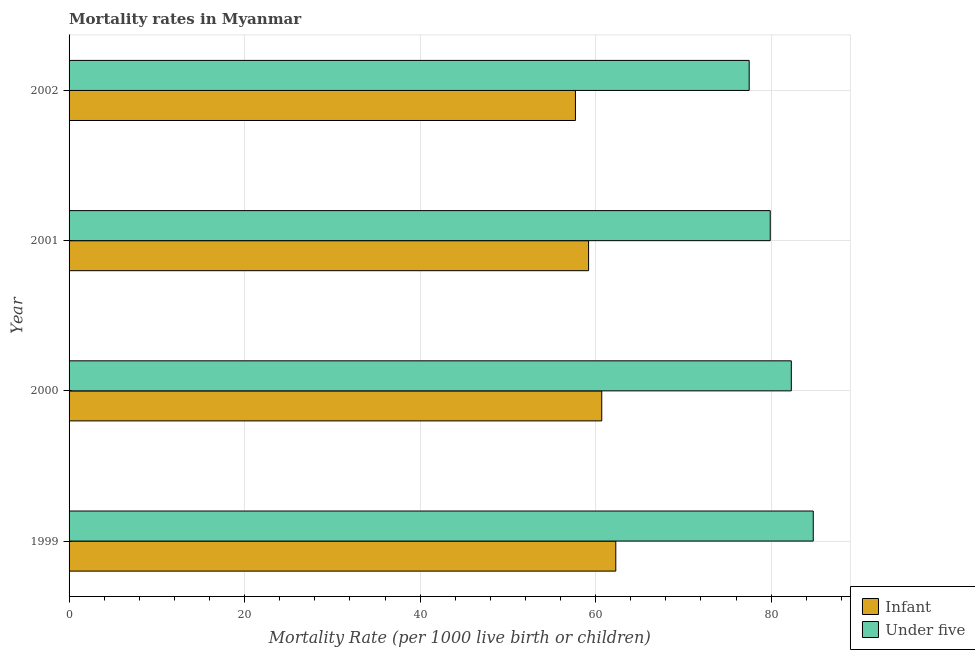How many groups of bars are there?
Ensure brevity in your answer.  4. Are the number of bars on each tick of the Y-axis equal?
Your response must be concise. Yes. How many bars are there on the 2nd tick from the top?
Provide a succinct answer. 2. How many bars are there on the 1st tick from the bottom?
Your answer should be very brief. 2. In how many cases, is the number of bars for a given year not equal to the number of legend labels?
Ensure brevity in your answer.  0. What is the under-5 mortality rate in 2001?
Ensure brevity in your answer.  79.9. Across all years, what is the maximum infant mortality rate?
Ensure brevity in your answer.  62.3. Across all years, what is the minimum under-5 mortality rate?
Keep it short and to the point. 77.5. In which year was the infant mortality rate maximum?
Offer a very short reply. 1999. In which year was the under-5 mortality rate minimum?
Your answer should be very brief. 2002. What is the total under-5 mortality rate in the graph?
Your answer should be very brief. 324.5. What is the difference between the under-5 mortality rate in 2000 and that in 2002?
Your answer should be compact. 4.8. What is the difference between the under-5 mortality rate in 2002 and the infant mortality rate in 2000?
Your answer should be very brief. 16.8. What is the average under-5 mortality rate per year?
Give a very brief answer. 81.12. In the year 1999, what is the difference between the under-5 mortality rate and infant mortality rate?
Provide a short and direct response. 22.5. What is the ratio of the infant mortality rate in 1999 to that in 2001?
Your answer should be compact. 1.05. Is the infant mortality rate in 2000 less than that in 2002?
Make the answer very short. No. Is the difference between the infant mortality rate in 2001 and 2002 greater than the difference between the under-5 mortality rate in 2001 and 2002?
Provide a short and direct response. No. What is the difference between the highest and the lowest under-5 mortality rate?
Your response must be concise. 7.3. In how many years, is the infant mortality rate greater than the average infant mortality rate taken over all years?
Your answer should be compact. 2. What does the 2nd bar from the top in 2000 represents?
Offer a very short reply. Infant. What does the 2nd bar from the bottom in 2000 represents?
Ensure brevity in your answer.  Under five. How many bars are there?
Keep it short and to the point. 8. What is the difference between two consecutive major ticks on the X-axis?
Offer a very short reply. 20. Does the graph contain any zero values?
Your response must be concise. No. What is the title of the graph?
Offer a very short reply. Mortality rates in Myanmar. What is the label or title of the X-axis?
Provide a short and direct response. Mortality Rate (per 1000 live birth or children). What is the label or title of the Y-axis?
Give a very brief answer. Year. What is the Mortality Rate (per 1000 live birth or children) of Infant in 1999?
Offer a very short reply. 62.3. What is the Mortality Rate (per 1000 live birth or children) in Under five in 1999?
Offer a very short reply. 84.8. What is the Mortality Rate (per 1000 live birth or children) in Infant in 2000?
Your response must be concise. 60.7. What is the Mortality Rate (per 1000 live birth or children) in Under five in 2000?
Ensure brevity in your answer.  82.3. What is the Mortality Rate (per 1000 live birth or children) in Infant in 2001?
Make the answer very short. 59.2. What is the Mortality Rate (per 1000 live birth or children) of Under five in 2001?
Ensure brevity in your answer.  79.9. What is the Mortality Rate (per 1000 live birth or children) in Infant in 2002?
Ensure brevity in your answer.  57.7. What is the Mortality Rate (per 1000 live birth or children) in Under five in 2002?
Your answer should be compact. 77.5. Across all years, what is the maximum Mortality Rate (per 1000 live birth or children) of Infant?
Offer a very short reply. 62.3. Across all years, what is the maximum Mortality Rate (per 1000 live birth or children) in Under five?
Provide a succinct answer. 84.8. Across all years, what is the minimum Mortality Rate (per 1000 live birth or children) in Infant?
Offer a very short reply. 57.7. Across all years, what is the minimum Mortality Rate (per 1000 live birth or children) in Under five?
Offer a terse response. 77.5. What is the total Mortality Rate (per 1000 live birth or children) of Infant in the graph?
Make the answer very short. 239.9. What is the total Mortality Rate (per 1000 live birth or children) in Under five in the graph?
Provide a succinct answer. 324.5. What is the difference between the Mortality Rate (per 1000 live birth or children) in Under five in 1999 and that in 2000?
Keep it short and to the point. 2.5. What is the difference between the Mortality Rate (per 1000 live birth or children) in Infant in 1999 and that in 2001?
Give a very brief answer. 3.1. What is the difference between the Mortality Rate (per 1000 live birth or children) in Infant in 1999 and that in 2002?
Offer a very short reply. 4.6. What is the difference between the Mortality Rate (per 1000 live birth or children) in Under five in 1999 and that in 2002?
Offer a very short reply. 7.3. What is the difference between the Mortality Rate (per 1000 live birth or children) of Under five in 2000 and that in 2002?
Ensure brevity in your answer.  4.8. What is the difference between the Mortality Rate (per 1000 live birth or children) in Infant in 2001 and that in 2002?
Your answer should be compact. 1.5. What is the difference between the Mortality Rate (per 1000 live birth or children) of Under five in 2001 and that in 2002?
Ensure brevity in your answer.  2.4. What is the difference between the Mortality Rate (per 1000 live birth or children) of Infant in 1999 and the Mortality Rate (per 1000 live birth or children) of Under five in 2001?
Offer a very short reply. -17.6. What is the difference between the Mortality Rate (per 1000 live birth or children) in Infant in 1999 and the Mortality Rate (per 1000 live birth or children) in Under five in 2002?
Offer a very short reply. -15.2. What is the difference between the Mortality Rate (per 1000 live birth or children) of Infant in 2000 and the Mortality Rate (per 1000 live birth or children) of Under five in 2001?
Make the answer very short. -19.2. What is the difference between the Mortality Rate (per 1000 live birth or children) in Infant in 2000 and the Mortality Rate (per 1000 live birth or children) in Under five in 2002?
Ensure brevity in your answer.  -16.8. What is the difference between the Mortality Rate (per 1000 live birth or children) in Infant in 2001 and the Mortality Rate (per 1000 live birth or children) in Under five in 2002?
Offer a terse response. -18.3. What is the average Mortality Rate (per 1000 live birth or children) in Infant per year?
Your response must be concise. 59.98. What is the average Mortality Rate (per 1000 live birth or children) in Under five per year?
Provide a succinct answer. 81.12. In the year 1999, what is the difference between the Mortality Rate (per 1000 live birth or children) in Infant and Mortality Rate (per 1000 live birth or children) in Under five?
Provide a short and direct response. -22.5. In the year 2000, what is the difference between the Mortality Rate (per 1000 live birth or children) of Infant and Mortality Rate (per 1000 live birth or children) of Under five?
Offer a terse response. -21.6. In the year 2001, what is the difference between the Mortality Rate (per 1000 live birth or children) in Infant and Mortality Rate (per 1000 live birth or children) in Under five?
Provide a short and direct response. -20.7. In the year 2002, what is the difference between the Mortality Rate (per 1000 live birth or children) of Infant and Mortality Rate (per 1000 live birth or children) of Under five?
Your answer should be compact. -19.8. What is the ratio of the Mortality Rate (per 1000 live birth or children) of Infant in 1999 to that in 2000?
Your answer should be very brief. 1.03. What is the ratio of the Mortality Rate (per 1000 live birth or children) in Under five in 1999 to that in 2000?
Ensure brevity in your answer.  1.03. What is the ratio of the Mortality Rate (per 1000 live birth or children) of Infant in 1999 to that in 2001?
Your answer should be very brief. 1.05. What is the ratio of the Mortality Rate (per 1000 live birth or children) of Under five in 1999 to that in 2001?
Make the answer very short. 1.06. What is the ratio of the Mortality Rate (per 1000 live birth or children) of Infant in 1999 to that in 2002?
Make the answer very short. 1.08. What is the ratio of the Mortality Rate (per 1000 live birth or children) of Under five in 1999 to that in 2002?
Ensure brevity in your answer.  1.09. What is the ratio of the Mortality Rate (per 1000 live birth or children) of Infant in 2000 to that in 2001?
Offer a very short reply. 1.03. What is the ratio of the Mortality Rate (per 1000 live birth or children) in Under five in 2000 to that in 2001?
Keep it short and to the point. 1.03. What is the ratio of the Mortality Rate (per 1000 live birth or children) in Infant in 2000 to that in 2002?
Your answer should be very brief. 1.05. What is the ratio of the Mortality Rate (per 1000 live birth or children) of Under five in 2000 to that in 2002?
Offer a very short reply. 1.06. What is the ratio of the Mortality Rate (per 1000 live birth or children) of Under five in 2001 to that in 2002?
Provide a succinct answer. 1.03. What is the difference between the highest and the second highest Mortality Rate (per 1000 live birth or children) of Under five?
Keep it short and to the point. 2.5. What is the difference between the highest and the lowest Mortality Rate (per 1000 live birth or children) in Infant?
Provide a succinct answer. 4.6. What is the difference between the highest and the lowest Mortality Rate (per 1000 live birth or children) in Under five?
Provide a short and direct response. 7.3. 